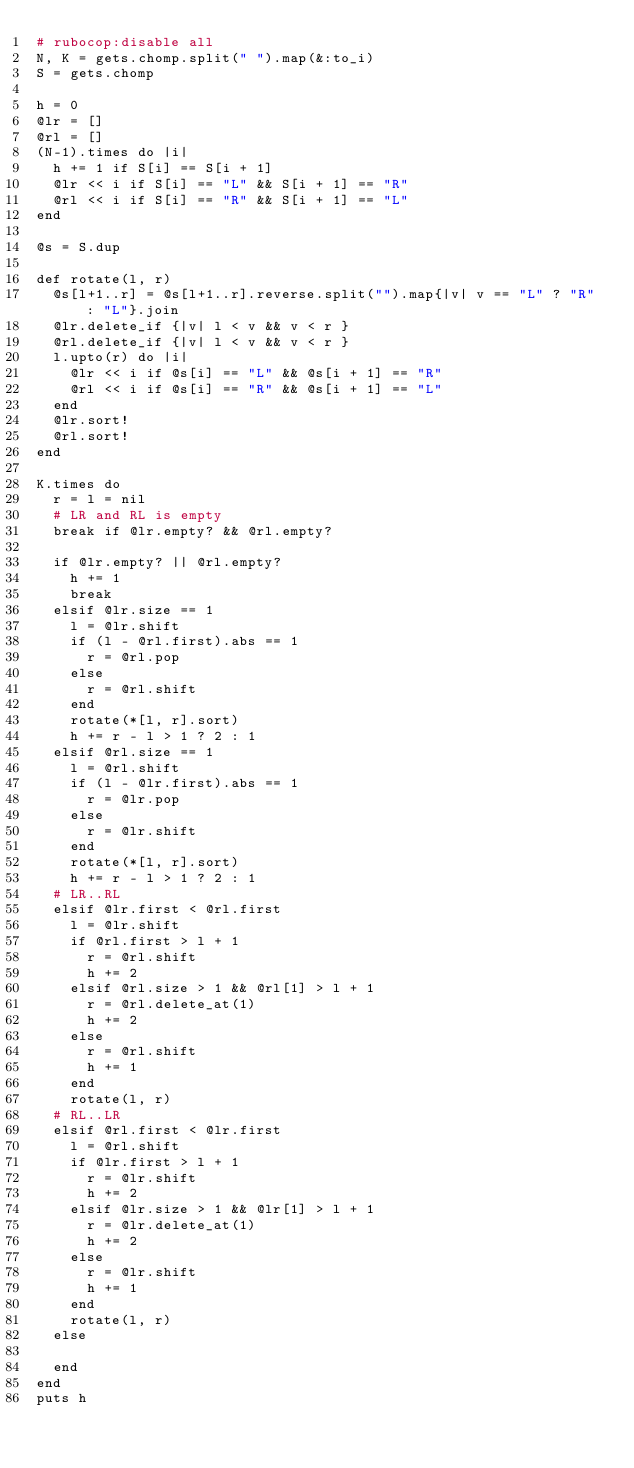Convert code to text. <code><loc_0><loc_0><loc_500><loc_500><_Ruby_># rubocop:disable all
N, K = gets.chomp.split(" ").map(&:to_i)
S = gets.chomp

h = 0
@lr = []
@rl = []
(N-1).times do |i|
  h += 1 if S[i] == S[i + 1]
  @lr << i if S[i] == "L" && S[i + 1] == "R"
  @rl << i if S[i] == "R" && S[i + 1] == "L"
end

@s = S.dup

def rotate(l, r)
  @s[l+1..r] = @s[l+1..r].reverse.split("").map{|v| v == "L" ? "R" : "L"}.join
  @lr.delete_if {|v| l < v && v < r }
  @rl.delete_if {|v| l < v && v < r }
  l.upto(r) do |i|
    @lr << i if @s[i] == "L" && @s[i + 1] == "R"
    @rl << i if @s[i] == "R" && @s[i + 1] == "L"
  end
  @lr.sort!
  @rl.sort!
end

K.times do
  r = l = nil
  # LR and RL is empty
  break if @lr.empty? && @rl.empty?

  if @lr.empty? || @rl.empty?
    h += 1
    break
  elsif @lr.size == 1
    l = @lr.shift
    if (l - @rl.first).abs == 1
      r = @rl.pop
    else
      r = @rl.shift
    end
    rotate(*[l, r].sort)
    h += r - l > 1 ? 2 : 1
  elsif @rl.size == 1
    l = @rl.shift
    if (l - @lr.first).abs == 1
      r = @lr.pop
    else
      r = @lr.shift
    end
    rotate(*[l, r].sort)
    h += r - l > 1 ? 2 : 1
  # LR..RL
  elsif @lr.first < @rl.first
    l = @lr.shift
    if @rl.first > l + 1
      r = @rl.shift
      h += 2
    elsif @rl.size > 1 && @rl[1] > l + 1
      r = @rl.delete_at(1)
      h += 2
    else
      r = @rl.shift
      h += 1
    end
    rotate(l, r)
  # RL..LR
  elsif @rl.first < @lr.first
    l = @rl.shift
    if @lr.first > l + 1
      r = @lr.shift
      h += 2
    elsif @lr.size > 1 && @lr[1] > l + 1
      r = @lr.delete_at(1)
      h += 2
    else
      r = @lr.shift
      h += 1
    end
    rotate(l, r)
  else

  end
end
puts h
</code> 